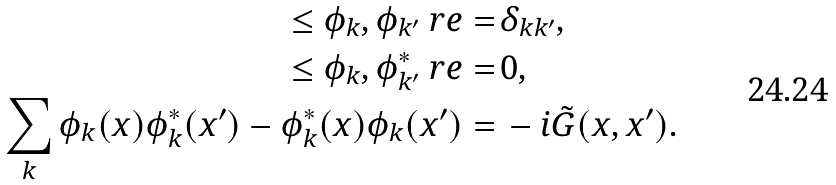Convert formula to latex. <formula><loc_0><loc_0><loc_500><loc_500>\leq \phi _ { k } , \phi _ { k ^ { \prime } } \ r e = & \, \delta _ { k k ^ { \prime } } , \\ \leq \phi _ { k } , \phi ^ { * } _ { k ^ { \prime } } \ r e = & \, 0 , \\ \sum _ { k } \phi _ { k } ( x ) \phi ^ { * } _ { k } ( x ^ { \prime } ) - \phi ^ { * } _ { k } ( x ) \phi _ { k } ( x ^ { \prime } ) = & \, - i \tilde { G } ( x , x ^ { \prime } ) .</formula> 